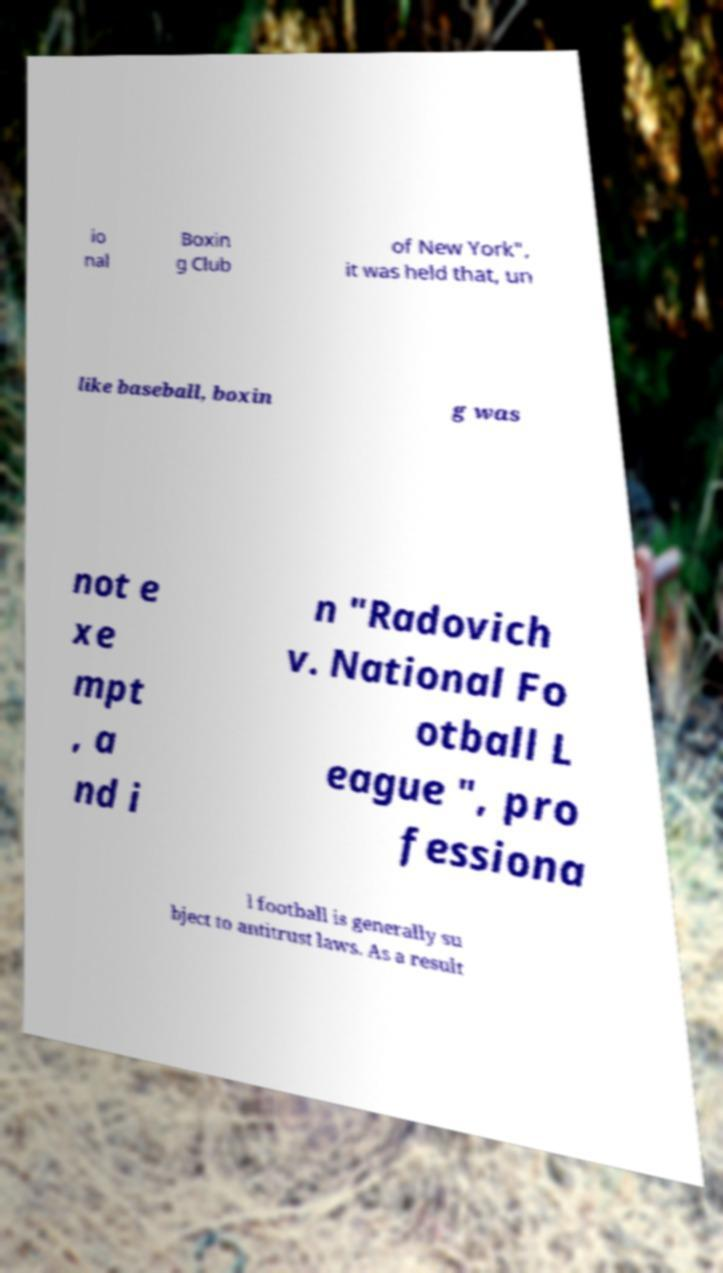What messages or text are displayed in this image? I need them in a readable, typed format. io nal Boxin g Club of New York", it was held that, un like baseball, boxin g was not e xe mpt , a nd i n "Radovich v. National Fo otball L eague ", pro fessiona l football is generally su bject to antitrust laws. As a result 